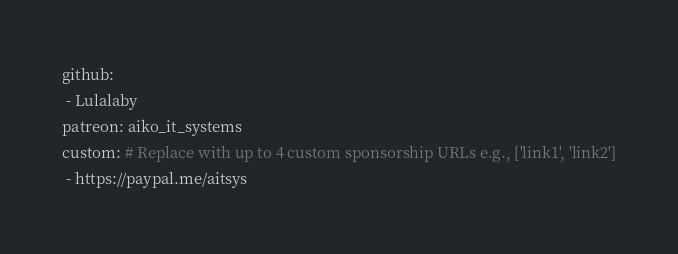Convert code to text. <code><loc_0><loc_0><loc_500><loc_500><_YAML_>github: 
 - Lulalaby
patreon: aiko_it_systems
custom: # Replace with up to 4 custom sponsorship URLs e.g., ['link1', 'link2']
 - https://paypal.me/aitsys
</code> 